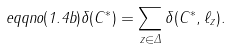<formula> <loc_0><loc_0><loc_500><loc_500>\ e q q n o ( 1 . 4 b ) \delta ( C ^ { * } ) = \sum _ { z \in \Delta } \delta ( C ^ { * } , \ell _ { z } ) .</formula> 